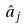Convert formula to latex. <formula><loc_0><loc_0><loc_500><loc_500>\hat { a } _ { j }</formula> 